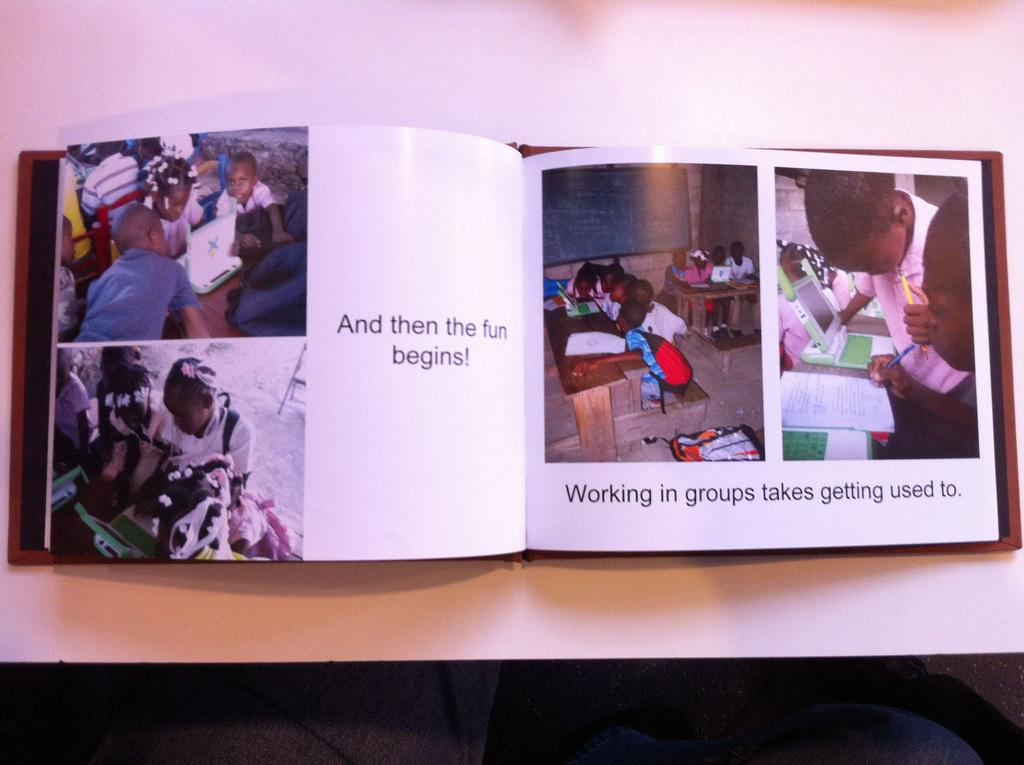What is present in the image related to reading material? There is a book in the image. What type of content is featured in the book? The book has pictures and text on it. Where is the book located in the image? The book is placed on a surface. How does the book grow in the image? The book does not grow in the image; it is a static object. What type of sound can be heard coming from the book in the image? There is no sound coming from the book in the image, as it is a still image. 